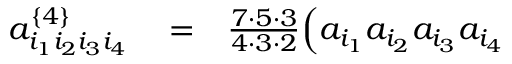<formula> <loc_0><loc_0><loc_500><loc_500>\begin{array} { r l r } { a _ { i _ { 1 } i _ { 2 } i _ { 3 } i _ { 4 } } ^ { \left \{ 4 \right \} } } & = } & { \frac { 7 \cdot 5 \cdot 3 } { 4 \cdot 3 \cdot 2 } \Big ( a _ { i _ { 1 } } a _ { i _ { 2 } } a _ { i _ { 3 } } a _ { i _ { 4 } } } \end{array}</formula> 